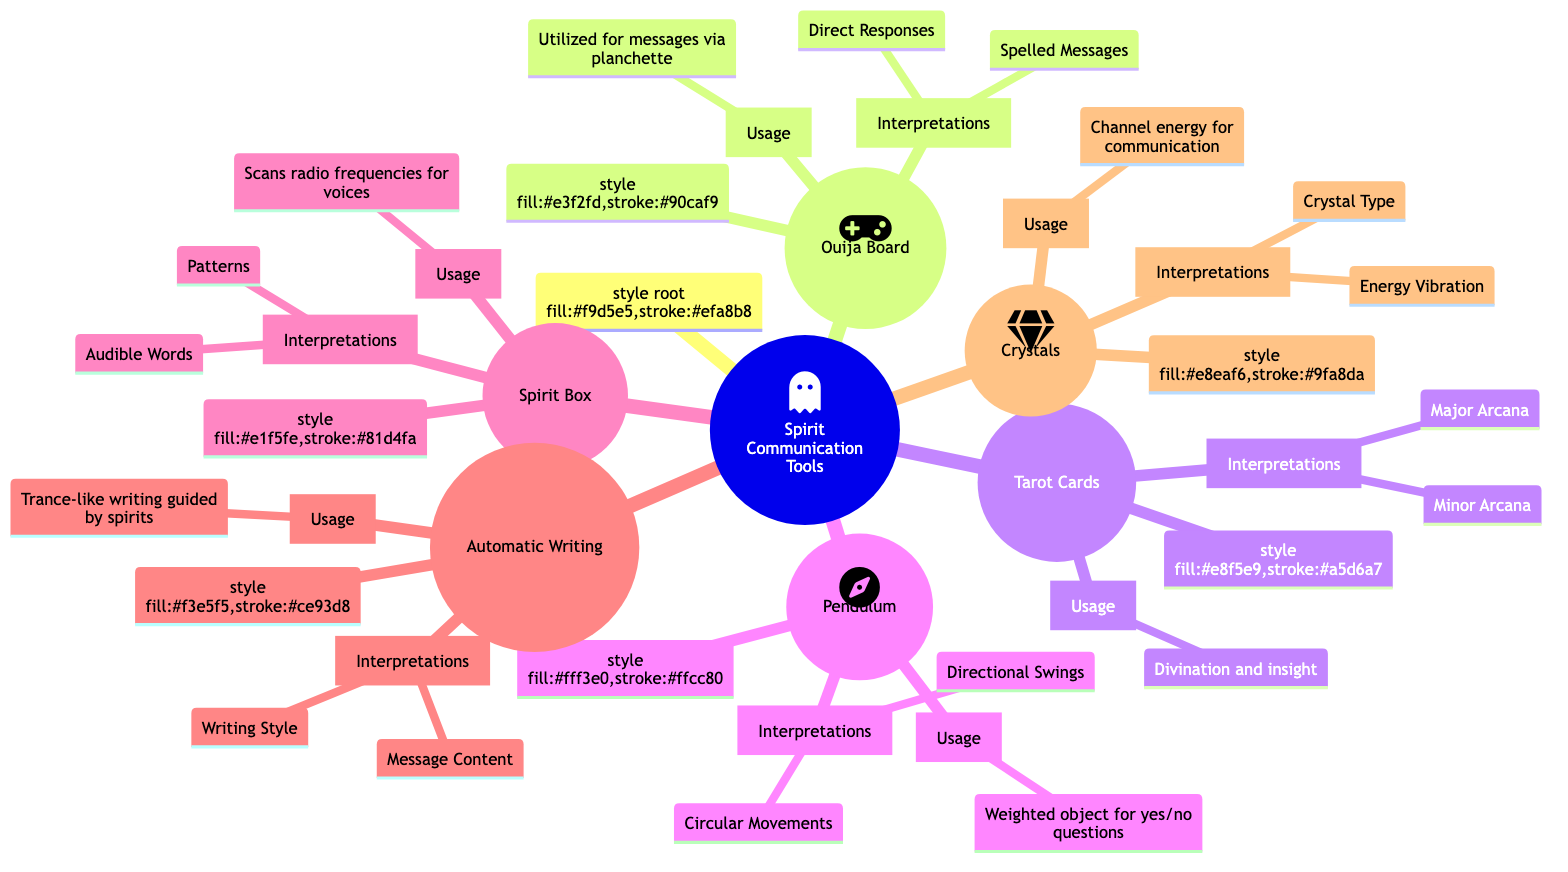What is the usage of the Ouija Board? The diagram states that the Ouija Board is utilized to spell out messages from spirits via a planchette. This information can be located directly under the "Ouija Board" node.
Answer: Utilized to spell out messages from spirits via a planchette How many tools are listed under Spirit Communication Tools? By counting the number of distinct tools directly connected to the root node "Spirit Communication Tools", we can tally a total of six tools: Ouija Board, Tarot Cards, Pendulum, Spirit Box, Automatic Writing, and Crystals.
Answer: 6 What are the interpretations of the Pendulum? The interpretations listed under the Pendulum node include "Directional Swings" and "Circular Movements." This can be found directly in the diagram beneath the Pendulum node.
Answer: Directional Swings, Circular Movements Which tool involves writing in a trance-like state? The diagram indicates that Automatic Writing involves a process where a person writes in a trance-like state guided by spirits. This information can be found directly under the Automatic Writing node.
Answer: Automatic Writing What kind of messages do Crystals facilitate? The diagram describes that Crystals are used to channel energy and facilitate communication. Specifically, they aid different kinds of communication with their types and subtle energy vibrations. This is found in the Usage section under Crystals.
Answer: To channel energy and facilitate communication What is indicated by circular movements of the Pendulum? According to the diagram, circular movements of the Pendulum are interpreted as uncertain or needing more clarity. This is explicitly stated in the interpretations section under Pendulum.
Answer: Uncertain or needing more clarity How does the Spirit Box function? The diagram details that the Spirit Box scans radio frequencies to capture spirit voices, which is found in the usage section beneath the Spirit Box node.
Answer: Scans radio frequencies to capture spirit voices What does the Major Arcana represent in Tarot Cards? The Major Arcana is mentioned in the diagram as representing significant spiritual events or influences, which is located under the interpretations section of the Tarot Cards node.
Answer: Significant spiritual events or influences 